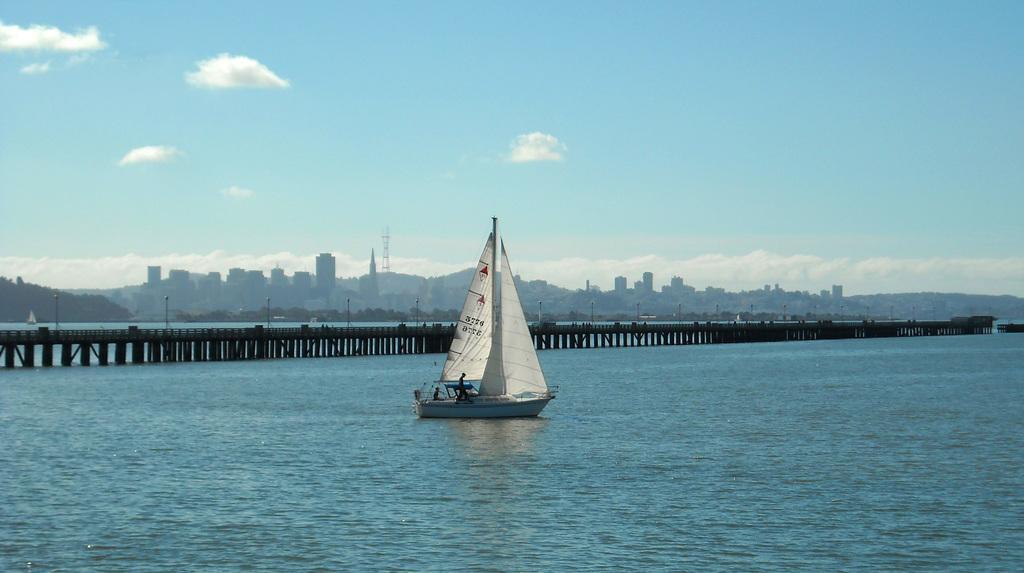Can you describe this image briefly? In this image I can see boats on the water. There are two persons, buildings, hills, there is a bridge and in the background there is sky. 